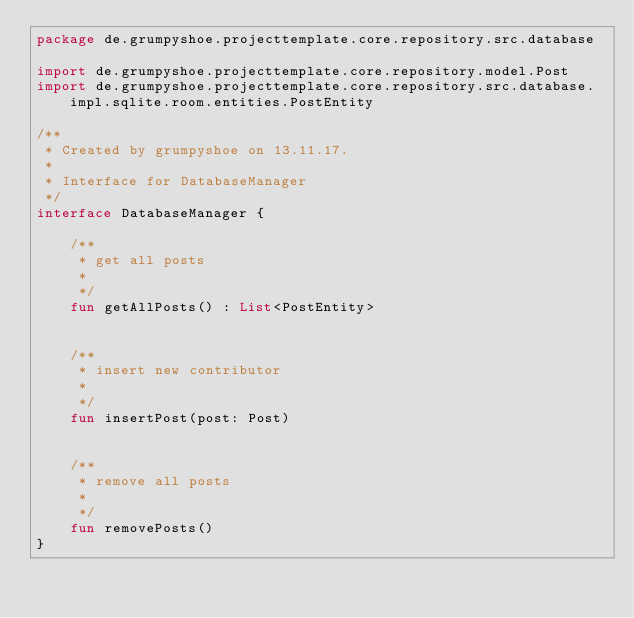<code> <loc_0><loc_0><loc_500><loc_500><_Kotlin_>package de.grumpyshoe.projecttemplate.core.repository.src.database

import de.grumpyshoe.projecttemplate.core.repository.model.Post
import de.grumpyshoe.projecttemplate.core.repository.src.database.impl.sqlite.room.entities.PostEntity

/**
 * Created by grumpyshoe on 13.11.17.
 *
 * Interface for DatabaseManager
 */
interface DatabaseManager {

    /**
     * get all posts
     *
     */
    fun getAllPosts() : List<PostEntity>


    /**
     * insert new contributor
     *
     */
    fun insertPost(post: Post)


    /**
     * remove all posts
     *
     */
    fun removePosts()
}</code> 